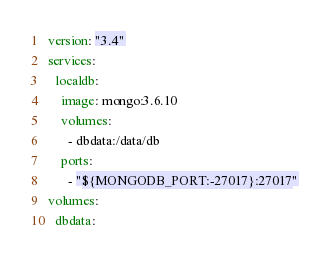Convert code to text. <code><loc_0><loc_0><loc_500><loc_500><_YAML_>version: "3.4"
services:
  localdb:
    image: mongo:3.6.10
    volumes:
      - dbdata:/data/db
    ports:
      - "${MONGODB_PORT:-27017}:27017"
volumes:
  dbdata:
</code> 